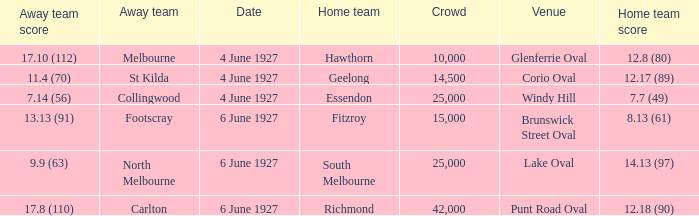Which team was at Corio Oval on 4 June 1927? St Kilda. Could you parse the entire table as a dict? {'header': ['Away team score', 'Away team', 'Date', 'Home team', 'Crowd', 'Venue', 'Home team score'], 'rows': [['17.10 (112)', 'Melbourne', '4 June 1927', 'Hawthorn', '10,000', 'Glenferrie Oval', '12.8 (80)'], ['11.4 (70)', 'St Kilda', '4 June 1927', 'Geelong', '14,500', 'Corio Oval', '12.17 (89)'], ['7.14 (56)', 'Collingwood', '4 June 1927', 'Essendon', '25,000', 'Windy Hill', '7.7 (49)'], ['13.13 (91)', 'Footscray', '6 June 1927', 'Fitzroy', '15,000', 'Brunswick Street Oval', '8.13 (61)'], ['9.9 (63)', 'North Melbourne', '6 June 1927', 'South Melbourne', '25,000', 'Lake Oval', '14.13 (97)'], ['17.8 (110)', 'Carlton', '6 June 1927', 'Richmond', '42,000', 'Punt Road Oval', '12.18 (90)']]} 